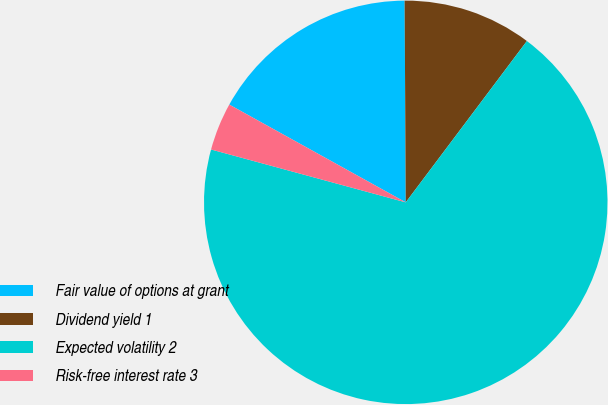<chart> <loc_0><loc_0><loc_500><loc_500><pie_chart><fcel>Fair value of options at grant<fcel>Dividend yield 1<fcel>Expected volatility 2<fcel>Risk-free interest rate 3<nl><fcel>16.86%<fcel>10.34%<fcel>68.97%<fcel>3.83%<nl></chart> 